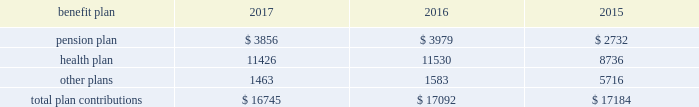112 / sl green realty corp .
2017 annual report 20 .
Commitments and contingencies legal proceedings as of december a031 , 2017 , the company and the operating partnership were not involved in any material litigation nor , to management 2019s knowledge , was any material litigation threat- ened against us or our portfolio which if adversely determined could have a material adverse impact on us .
Environmental matters our management believes that the properties are in compliance in all material respects with applicable federal , state and local ordinances and regulations regarding environmental issues .
Management is not aware of any environmental liability that it believes would have a materially adverse impact on our financial position , results of operations or cash flows .
Management is unaware of any instances in which it would incur significant envi- ronmental cost if any of our properties were sold .
Employment agreements we have entered into employment agreements with certain exec- utives , which expire between december a02018 and february a02020 .
The minimum cash-based compensation , including base sal- ary and guaranteed bonus payments , associated with these employment agreements total $ 5.4 a0million for 2018 .
In addition these employment agreements provide for deferred compen- sation awards based on our stock price and which were valued at $ 1.6 a0million on the grant date .
The value of these awards may change based on fluctuations in our stock price .
Insurance we maintain 201call-risk 201d property and rental value coverage ( includ- ing coverage regarding the perils of flood , earthquake and terrorism , excluding nuclear , biological , chemical , and radiological terrorism ( 201cnbcr 201d ) ) , within three property insurance programs and liability insurance .
Separate property and liability coverage may be purchased on a stand-alone basis for certain assets , such as the development of one vanderbilt .
Additionally , our captive insurance company , belmont insurance company , or belmont , pro- vides coverage for nbcr terrorist acts above a specified trigger , although if belmont is required to pay a claim under our insur- ance policies , we would ultimately record the loss to the extent of belmont 2019s required payment .
However , there is no assurance that in the future we will be able to procure coverage at a reasonable cost .
Further , if we experience losses that are uninsured or that exceed policy limits , we could lose the capital invested in the damaged properties as well as the anticipated future cash flows from those plan trustees adopted a rehabilitation plan consistent with this requirement .
No surcharges have been paid to the pension plan as of december a031 , 2017 .
For the pension plan years ended june a030 , 2017 , 2016 , and 2015 , the plan received contributions from employers totaling $ 257.8 a0million , $ 249.5 a0million , and $ 221.9 a0million .
Our contributions to the pension plan represent less than 5.0% ( 5.0 % ) of total contributions to the plan .
The health plan was established under the terms of collective bargaining agreements between the union , the realty advisory board on labor relations , inc .
And certain other employees .
The health plan provides health and other benefits to eligible participants employed in the building service industry who are covered under collective bargaining agreements , or other writ- ten agreements , with the union .
The health plan is administered by a board of trustees with equal representation by the employ- ers and the union and operates under employer identification number a013-2928869 .
The health plan receives contributions in accordance with collective bargaining agreements or participa- tion agreements .
Generally , these agreements provide that the employers contribute to the health plan at a fixed rate on behalf of each covered employee .
For the health plan years ended , june a030 , 2017 , 2016 , and 2015 , the plan received contributions from employers totaling $ 1.3 a0billion , $ 1.2 a0billion and $ 1.1 a0billion , respectively .
Our contributions to the health plan represent less than 5.0% ( 5.0 % ) of total contributions to the plan .
Contributions we made to the multi-employer plans for the years ended december a031 , 2017 , 2016 and 2015 are included in the table below ( in thousands ) : .
401 ( k ) plan in august a01997 , we implemented a 401 ( k ) a0savings/retirement plan , or the 401 ( k ) a0plan , to cover eligible employees of ours , and any designated affiliate .
The 401 ( k ) a0plan permits eligible employees to defer up to 15% ( 15 % ) of their annual compensation , subject to certain limitations imposed by the code .
The employees 2019 elective deferrals are immediately vested and non-forfeitable upon contribution to the 401 ( k ) a0plan .
During a02003 , we amended our 401 ( k ) a0plan to pro- vide for discretionary matching contributions only .
For 2017 , 2016 and 2015 , a matching contribution equal to 50% ( 50 % ) of the first 6% ( 6 % ) of annual compensation was made .
For the year ended december a031 , 2017 , we made a matching contribution of $ 728782 .
For the years ended december a031 , 2016 and 2015 , we made matching contribu- tions of $ 566000 and $ 550000 , respectively. .
In 2017 what was the percent of the total plan contributions we made to the multi-employer plans that was for pension? 
Computations: (3856 / 16745)
Answer: 0.23028. 